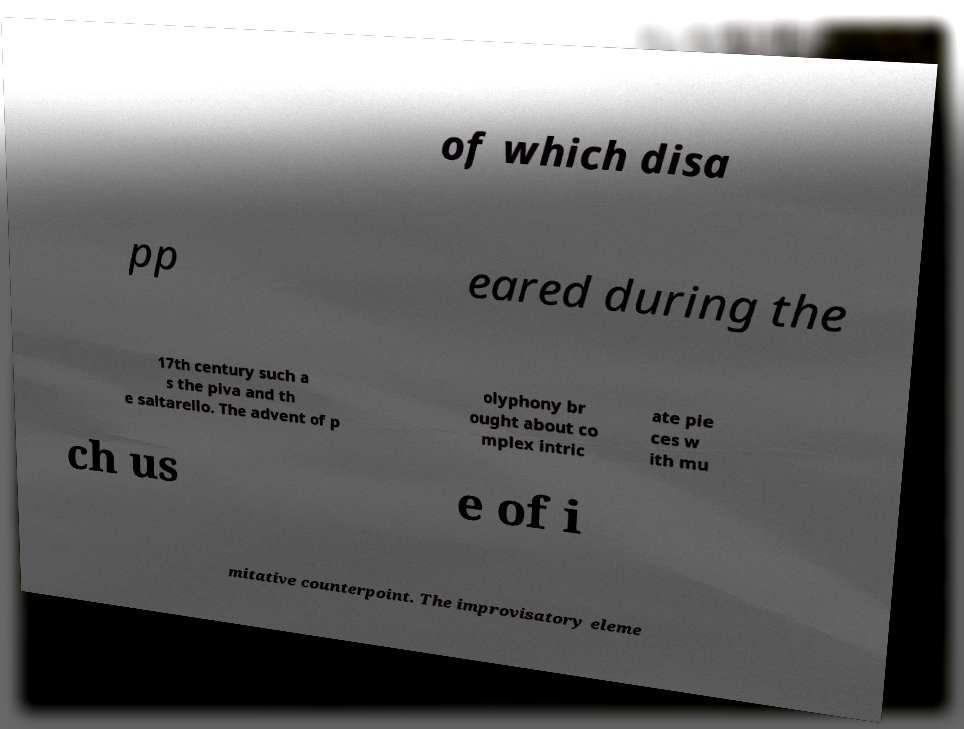Please read and relay the text visible in this image. What does it say? of which disa pp eared during the 17th century such a s the piva and th e saltarello. The advent of p olyphony br ought about co mplex intric ate pie ces w ith mu ch us e of i mitative counterpoint. The improvisatory eleme 